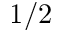<formula> <loc_0><loc_0><loc_500><loc_500>1 / 2</formula> 